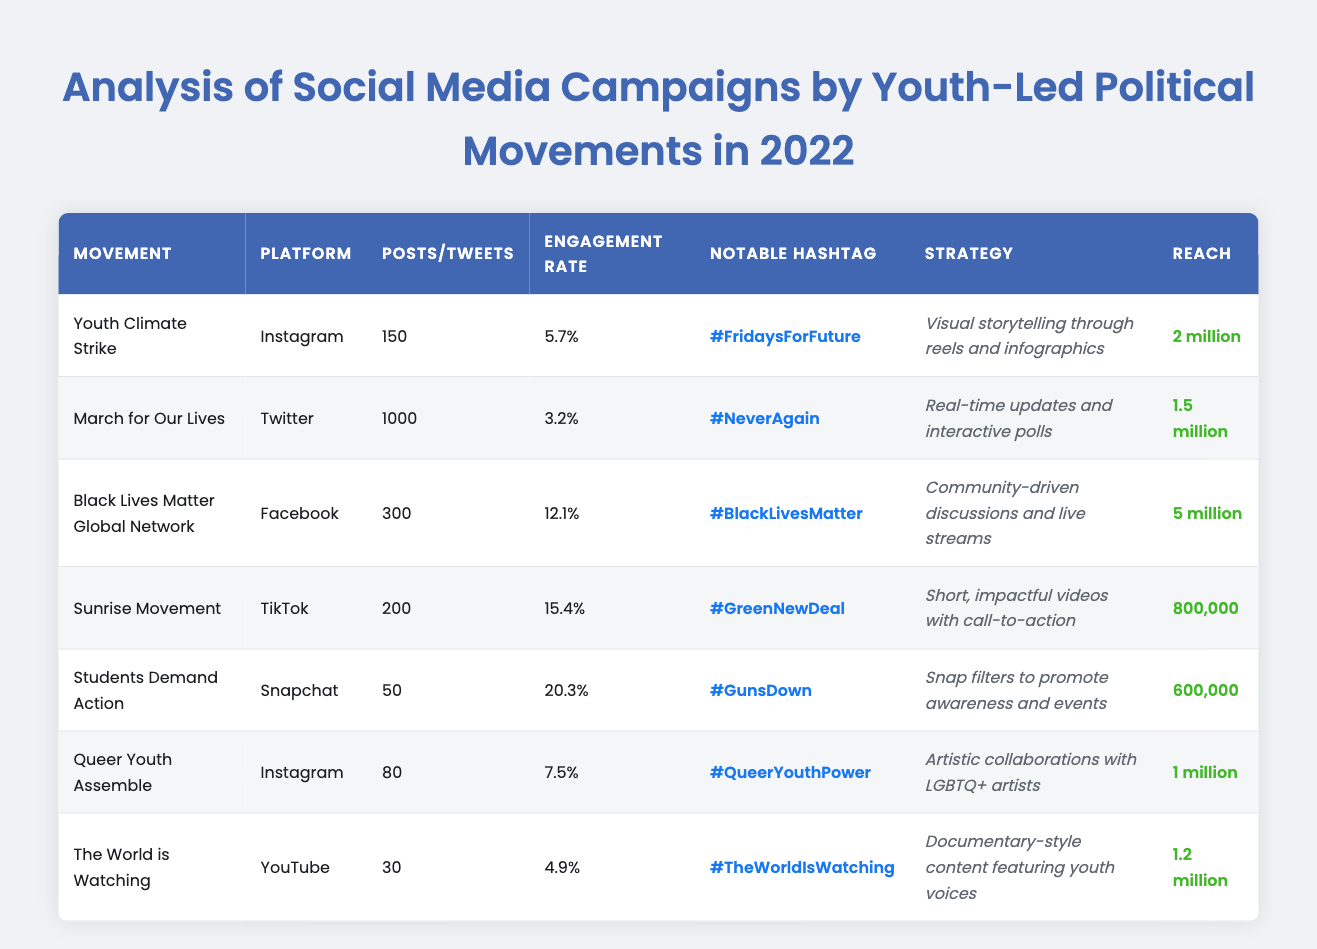What is the engagement rate of the Sunrise Movement? The table shows the engagement rate for the Sunrise Movement under the 'Engagement Rate' column, which is 15.4%.
Answer: 15.4% Which platform had the highest reach among the campaigns? By comparing the 'Reach' column, Black Lives Matter Global Network has the highest reach of 5 million.
Answer: 5 million How many posts did the Youth Climate Strike make? The number of posts made by the Youth Climate Strike is listed as 150 in the 'Posts' column.
Answer: 150 Does the March for Our Lives campaign have an engagement rate above 4%? The engagement rate for March for Our Lives is 3.2%, which is below 4%, making the statement false.
Answer: No What is the average engagement rate of all campaigns listed? The engagement rates are: 5.7%, 3.2%, 12.1%, 15.4%, 20.3%, 7.5%, and 4.9%. Adding these gives 69.1%, and dividing by 7 campaigns gives an average of 9.87%.
Answer: 9.87% Which two movements had the highest engagement rates? The highest engagement rates are 20.3% for Students Demand Action and 15.4% for Sunrise Movement.
Answer: Students Demand Action and Sunrise Movement Are more posts created on Twitter or Instagram? Instagram has a total of 230 posts (150 from Youth Climate Strike + 80 from Queer Youth Assemble), while Twitter has 1000 tweets. Since 1000 > 230, Twitter has more posts.
Answer: Twitter What is the difference in reach between Students Demand Action and Sunrise Movement? Students Demand Action has a reach of 600,000 while Sunrise Movement has 800,000. The difference is 800,000 - 600,000 = 200,000.
Answer: 200,000 What campaign utilized TikTok as their platform? The Sunrise Movement utilized TikTok as their platform, as stated in the 'Platform' column.
Answer: Sunrise Movement Which movement had the lowest reach? By comparing the 'Reach' column, Students Demand Action had the lowest reach at 600,000.
Answer: Students Demand Action How many platforms were used for campaigns that had an engagement rate over 10%? The campaigns with engagement rates over 10% are Black Lives Matter Global Network (Facebook), Sunrise Movement (TikTok), and Students Demand Action (Snapchat). This totals 3 different platforms.
Answer: 3 